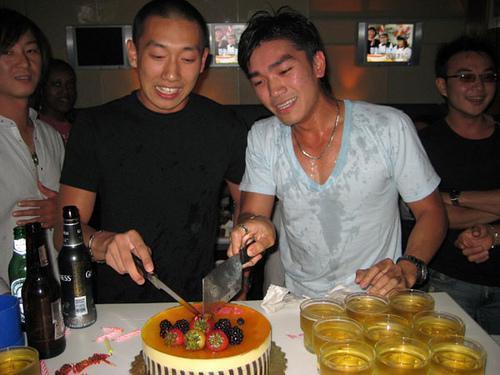How many bottles are in the picture?
Give a very brief answer. 2. How many people are there?
Give a very brief answer. 5. How many tvs are in the photo?
Give a very brief answer. 2. 